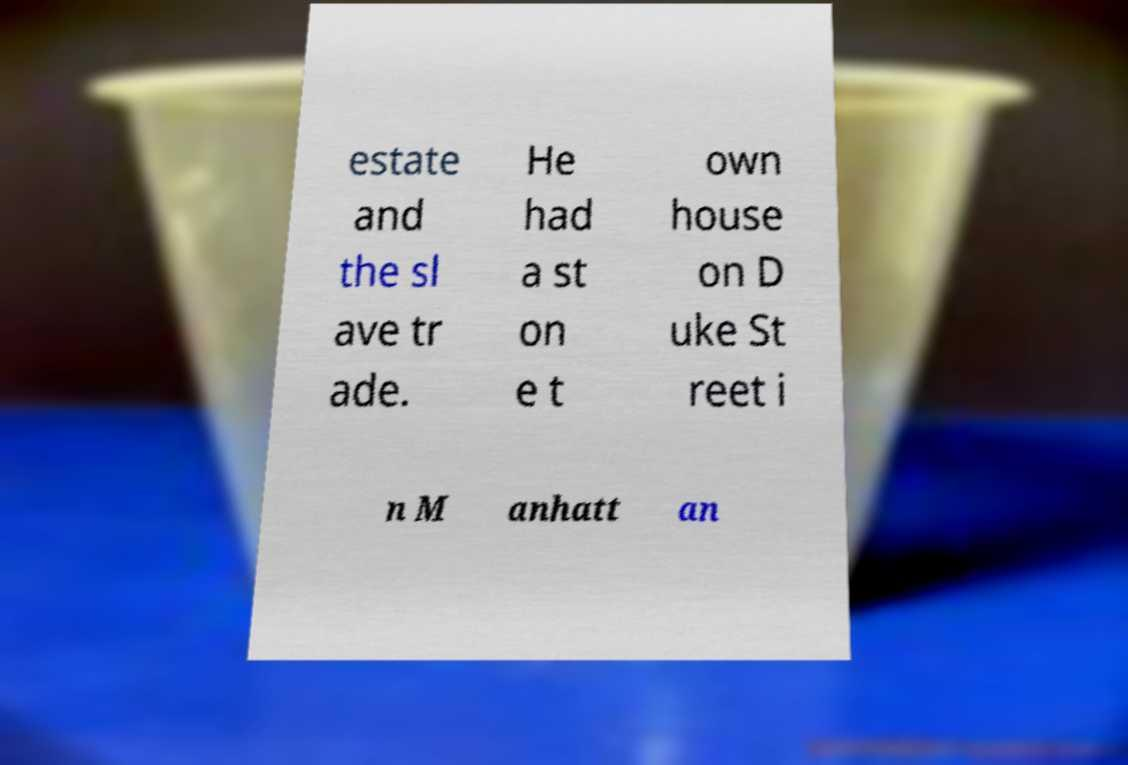For documentation purposes, I need the text within this image transcribed. Could you provide that? estate and the sl ave tr ade. He had a st on e t own house on D uke St reet i n M anhatt an 